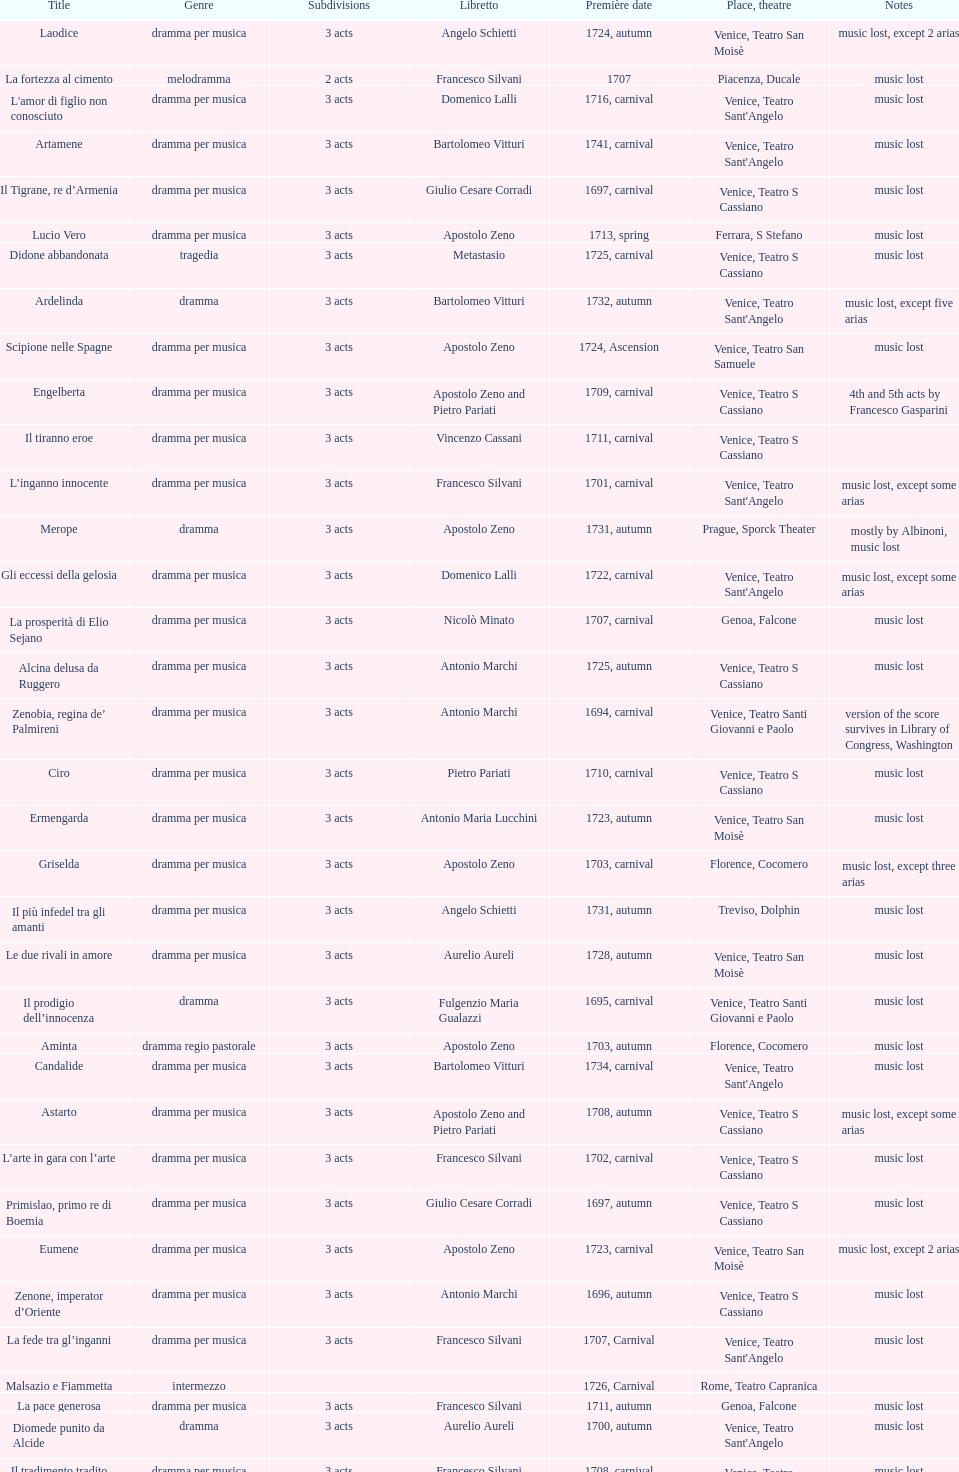Which opera has the most acts, la fortezza al cimento or astarto? Astarto. 